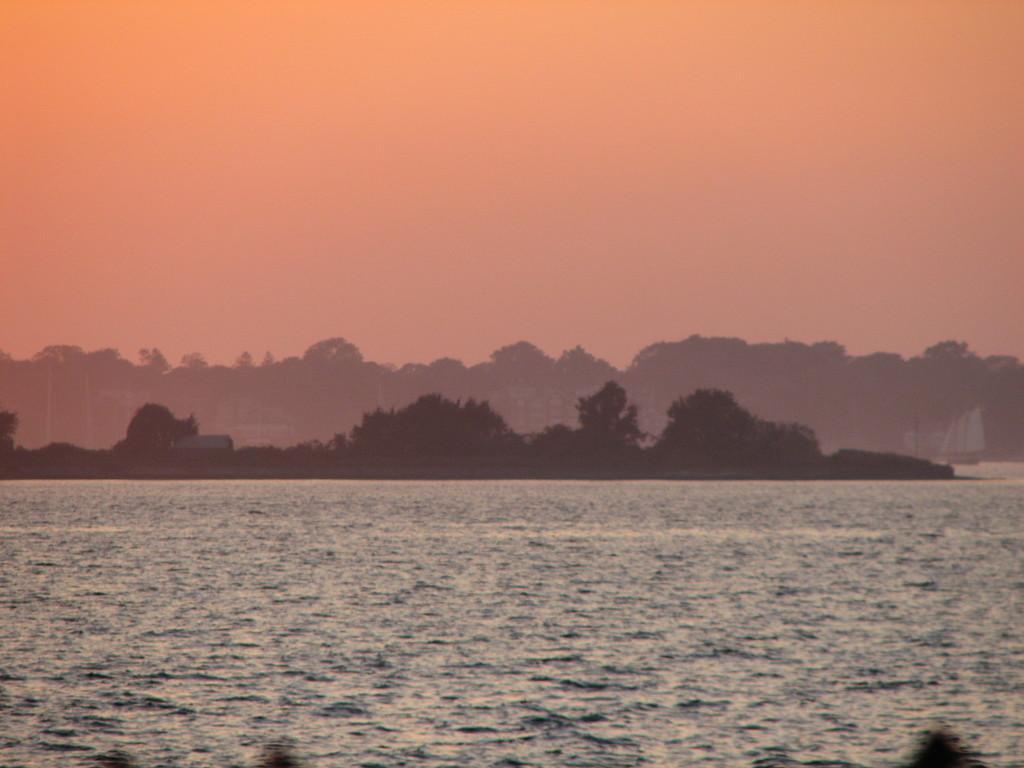Can you describe this image briefly? At the bottom of the picture, we see water and this water might be in the sea or in the lake. There are trees in the background. On the right side, we see a ship is sailing on the water. At the top of the picture, we see the sky. 